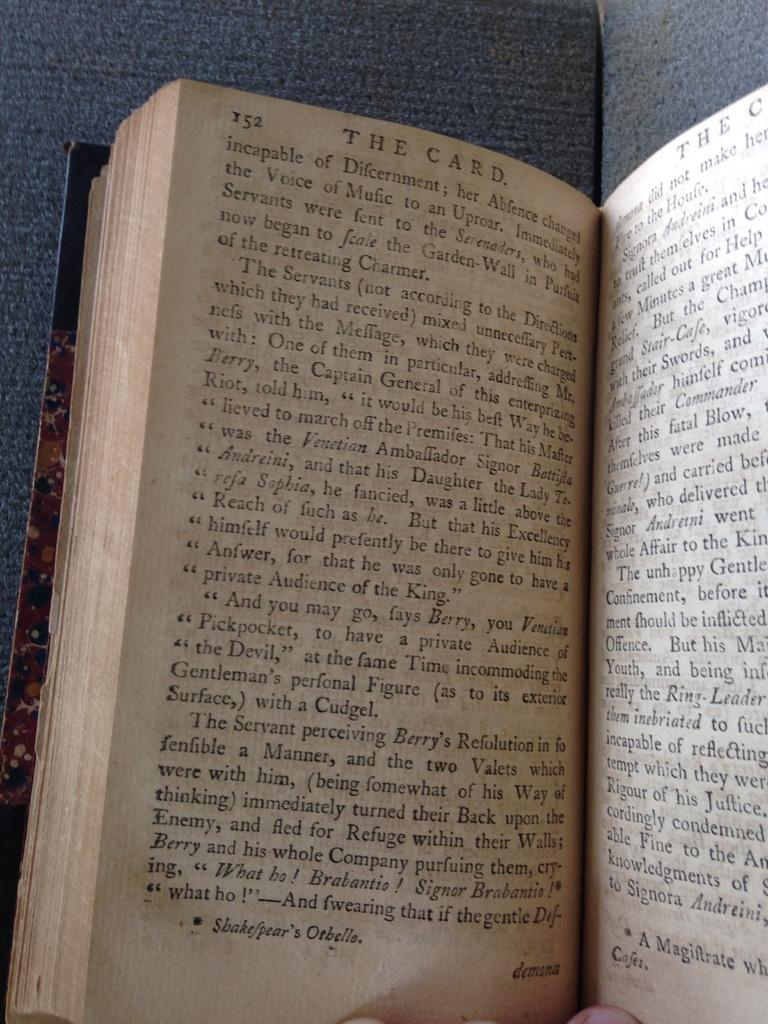<image>
Render a clear and concise summary of the photo. A book titled "The Card" is open to page 152. 